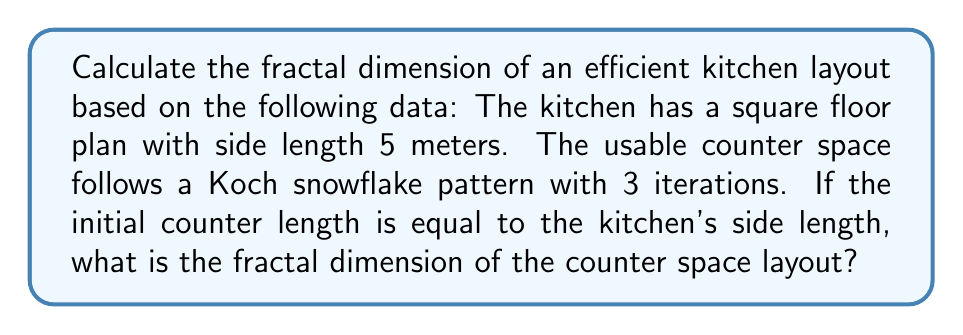Give your solution to this math problem. To solve this problem, we'll follow these steps:

1) Recall the formula for fractal dimension:

   $$D = \frac{\log N}{\log r}$$

   Where $N$ is the number of self-similar pieces and $r$ is the scaling factor.

2) For a Koch snowflake:
   - Each line segment is replaced by 4 smaller segments in each iteration.
   - The length of each new segment is 1/3 of the original.

3) Therefore, for the Koch snowflake:
   $N = 4$ (number of self-similar pieces)
   $r = 1/3$ (scaling factor)

4) Plugging these values into our formula:

   $$D = \frac{\log 4}{\log (1/3)}$$

5) Simplify:
   $$D = \frac{\log 4}{\log 1 - \log 3} = \frac{\log 4}{-\log 3}$$

6) Calculate:
   $$D \approx 1.2618595071429148$$

This fractal dimension indicates that the counter space layout is more complex than a simple line (dimension 1) but less space-filling than a plane (dimension 2), which is characteristic of an efficient use of space in kitchen design.
Answer: $D \approx 1.2619$ 